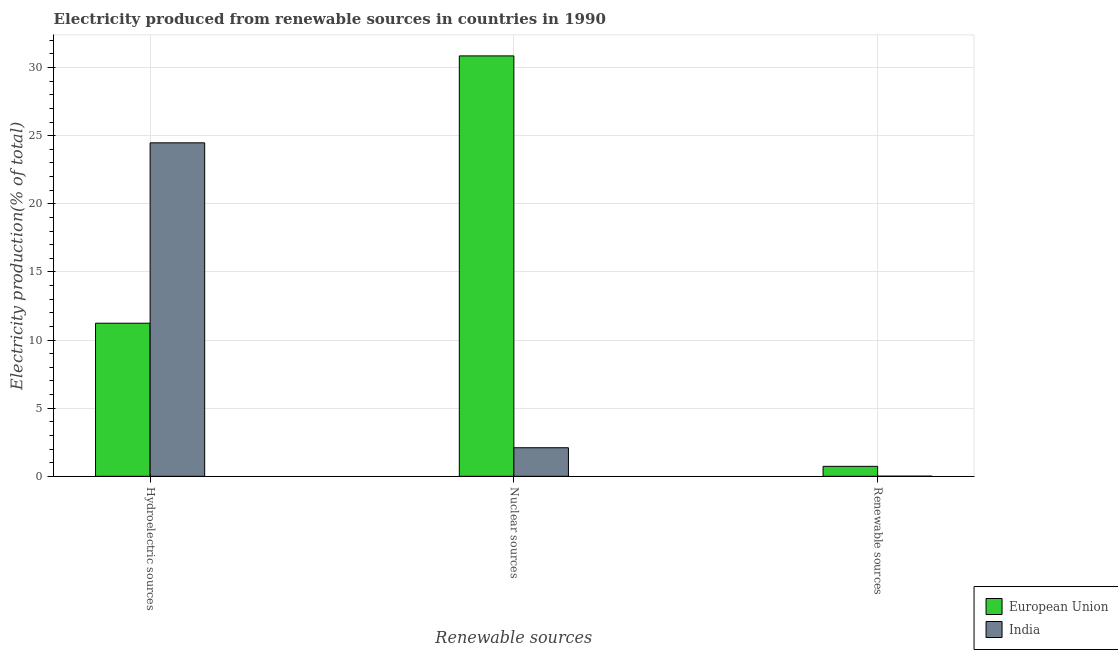How many different coloured bars are there?
Provide a succinct answer. 2. How many groups of bars are there?
Your answer should be compact. 3. How many bars are there on the 3rd tick from the left?
Your answer should be very brief. 2. What is the label of the 1st group of bars from the left?
Ensure brevity in your answer.  Hydroelectric sources. What is the percentage of electricity produced by hydroelectric sources in India?
Your answer should be very brief. 24.48. Across all countries, what is the maximum percentage of electricity produced by renewable sources?
Your answer should be compact. 0.73. Across all countries, what is the minimum percentage of electricity produced by renewable sources?
Provide a succinct answer. 0.01. What is the total percentage of electricity produced by renewable sources in the graph?
Offer a terse response. 0.74. What is the difference between the percentage of electricity produced by hydroelectric sources in European Union and that in India?
Your answer should be very brief. -13.24. What is the difference between the percentage of electricity produced by nuclear sources in European Union and the percentage of electricity produced by renewable sources in India?
Provide a succinct answer. 30.85. What is the average percentage of electricity produced by hydroelectric sources per country?
Offer a terse response. 17.86. What is the difference between the percentage of electricity produced by hydroelectric sources and percentage of electricity produced by renewable sources in India?
Your answer should be very brief. 24.47. What is the ratio of the percentage of electricity produced by nuclear sources in European Union to that in India?
Make the answer very short. 14.71. Is the percentage of electricity produced by nuclear sources in European Union less than that in India?
Keep it short and to the point. No. Is the difference between the percentage of electricity produced by nuclear sources in European Union and India greater than the difference between the percentage of electricity produced by renewable sources in European Union and India?
Offer a very short reply. Yes. What is the difference between the highest and the second highest percentage of electricity produced by renewable sources?
Provide a succinct answer. 0.72. What is the difference between the highest and the lowest percentage of electricity produced by renewable sources?
Make the answer very short. 0.72. What does the 1st bar from the left in Hydroelectric sources represents?
Your response must be concise. European Union. What does the 2nd bar from the right in Renewable sources represents?
Provide a succinct answer. European Union. How many bars are there?
Offer a terse response. 6. Are all the bars in the graph horizontal?
Provide a succinct answer. No. How many countries are there in the graph?
Give a very brief answer. 2. What is the difference between two consecutive major ticks on the Y-axis?
Offer a terse response. 5. Does the graph contain any zero values?
Ensure brevity in your answer.  No. Does the graph contain grids?
Provide a succinct answer. Yes. How are the legend labels stacked?
Make the answer very short. Vertical. What is the title of the graph?
Provide a succinct answer. Electricity produced from renewable sources in countries in 1990. What is the label or title of the X-axis?
Your answer should be very brief. Renewable sources. What is the label or title of the Y-axis?
Your answer should be compact. Electricity production(% of total). What is the Electricity production(% of total) of European Union in Hydroelectric sources?
Offer a terse response. 11.24. What is the Electricity production(% of total) in India in Hydroelectric sources?
Your response must be concise. 24.48. What is the Electricity production(% of total) in European Union in Nuclear sources?
Provide a succinct answer. 30.86. What is the Electricity production(% of total) in India in Nuclear sources?
Your response must be concise. 2.1. What is the Electricity production(% of total) in European Union in Renewable sources?
Give a very brief answer. 0.73. What is the Electricity production(% of total) in India in Renewable sources?
Your response must be concise. 0.01. Across all Renewable sources, what is the maximum Electricity production(% of total) in European Union?
Ensure brevity in your answer.  30.86. Across all Renewable sources, what is the maximum Electricity production(% of total) in India?
Give a very brief answer. 24.48. Across all Renewable sources, what is the minimum Electricity production(% of total) of European Union?
Offer a terse response. 0.73. Across all Renewable sources, what is the minimum Electricity production(% of total) of India?
Ensure brevity in your answer.  0.01. What is the total Electricity production(% of total) of European Union in the graph?
Provide a short and direct response. 42.83. What is the total Electricity production(% of total) in India in the graph?
Offer a very short reply. 26.59. What is the difference between the Electricity production(% of total) in European Union in Hydroelectric sources and that in Nuclear sources?
Offer a terse response. -19.62. What is the difference between the Electricity production(% of total) of India in Hydroelectric sources and that in Nuclear sources?
Make the answer very short. 22.38. What is the difference between the Electricity production(% of total) in European Union in Hydroelectric sources and that in Renewable sources?
Your response must be concise. 10.51. What is the difference between the Electricity production(% of total) in India in Hydroelectric sources and that in Renewable sources?
Your response must be concise. 24.47. What is the difference between the Electricity production(% of total) in European Union in Nuclear sources and that in Renewable sources?
Your answer should be very brief. 30.13. What is the difference between the Electricity production(% of total) of India in Nuclear sources and that in Renewable sources?
Provide a short and direct response. 2.09. What is the difference between the Electricity production(% of total) in European Union in Hydroelectric sources and the Electricity production(% of total) in India in Nuclear sources?
Provide a succinct answer. 9.14. What is the difference between the Electricity production(% of total) in European Union in Hydroelectric sources and the Electricity production(% of total) in India in Renewable sources?
Your response must be concise. 11.23. What is the difference between the Electricity production(% of total) of European Union in Nuclear sources and the Electricity production(% of total) of India in Renewable sources?
Your answer should be very brief. 30.85. What is the average Electricity production(% of total) of European Union per Renewable sources?
Give a very brief answer. 14.28. What is the average Electricity production(% of total) in India per Renewable sources?
Provide a succinct answer. 8.86. What is the difference between the Electricity production(% of total) of European Union and Electricity production(% of total) of India in Hydroelectric sources?
Your answer should be compact. -13.24. What is the difference between the Electricity production(% of total) of European Union and Electricity production(% of total) of India in Nuclear sources?
Your answer should be compact. 28.76. What is the difference between the Electricity production(% of total) of European Union and Electricity production(% of total) of India in Renewable sources?
Provide a succinct answer. 0.72. What is the ratio of the Electricity production(% of total) in European Union in Hydroelectric sources to that in Nuclear sources?
Provide a succinct answer. 0.36. What is the ratio of the Electricity production(% of total) in India in Hydroelectric sources to that in Nuclear sources?
Offer a very short reply. 11.67. What is the ratio of the Electricity production(% of total) in European Union in Hydroelectric sources to that in Renewable sources?
Your answer should be compact. 15.35. What is the ratio of the Electricity production(% of total) of India in Hydroelectric sources to that in Renewable sources?
Your answer should be compact. 2239.25. What is the ratio of the Electricity production(% of total) in European Union in Nuclear sources to that in Renewable sources?
Give a very brief answer. 42.15. What is the ratio of the Electricity production(% of total) in India in Nuclear sources to that in Renewable sources?
Provide a succinct answer. 191.91. What is the difference between the highest and the second highest Electricity production(% of total) in European Union?
Your response must be concise. 19.62. What is the difference between the highest and the second highest Electricity production(% of total) in India?
Your answer should be very brief. 22.38. What is the difference between the highest and the lowest Electricity production(% of total) in European Union?
Provide a succinct answer. 30.13. What is the difference between the highest and the lowest Electricity production(% of total) in India?
Keep it short and to the point. 24.47. 